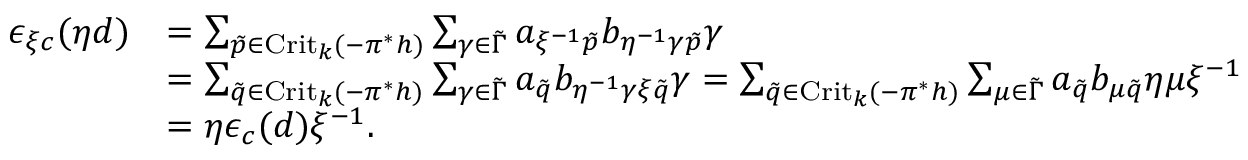Convert formula to latex. <formula><loc_0><loc_0><loc_500><loc_500>\begin{array} { r l } { \epsilon _ { \xi c } ( \eta d ) } & { = \sum _ { \tilde { p } \in C r i t _ { k } ( - \pi ^ { * } h ) } \sum _ { \gamma \in \tilde { \Gamma } } a _ { \xi ^ { - 1 } \tilde { p } } b _ { \eta ^ { - 1 } \gamma \tilde { p } } \gamma } \\ & { = \sum _ { \tilde { q } \in C r i t _ { k } ( - \pi ^ { * } h ) } \sum _ { \gamma \in \tilde { \Gamma } } a _ { \tilde { q } } b _ { \eta ^ { - 1 } \gamma \xi \tilde { q } } \gamma = \sum _ { \tilde { q } \in C r i t _ { k } ( - \pi ^ { * } h ) } \sum _ { \mu \in \tilde { \Gamma } } a _ { \tilde { q } } b _ { \mu \tilde { q } } \eta \mu \xi ^ { - 1 } } \\ & { = \eta \epsilon _ { c } ( d ) \xi ^ { - 1 } . } \end{array}</formula> 